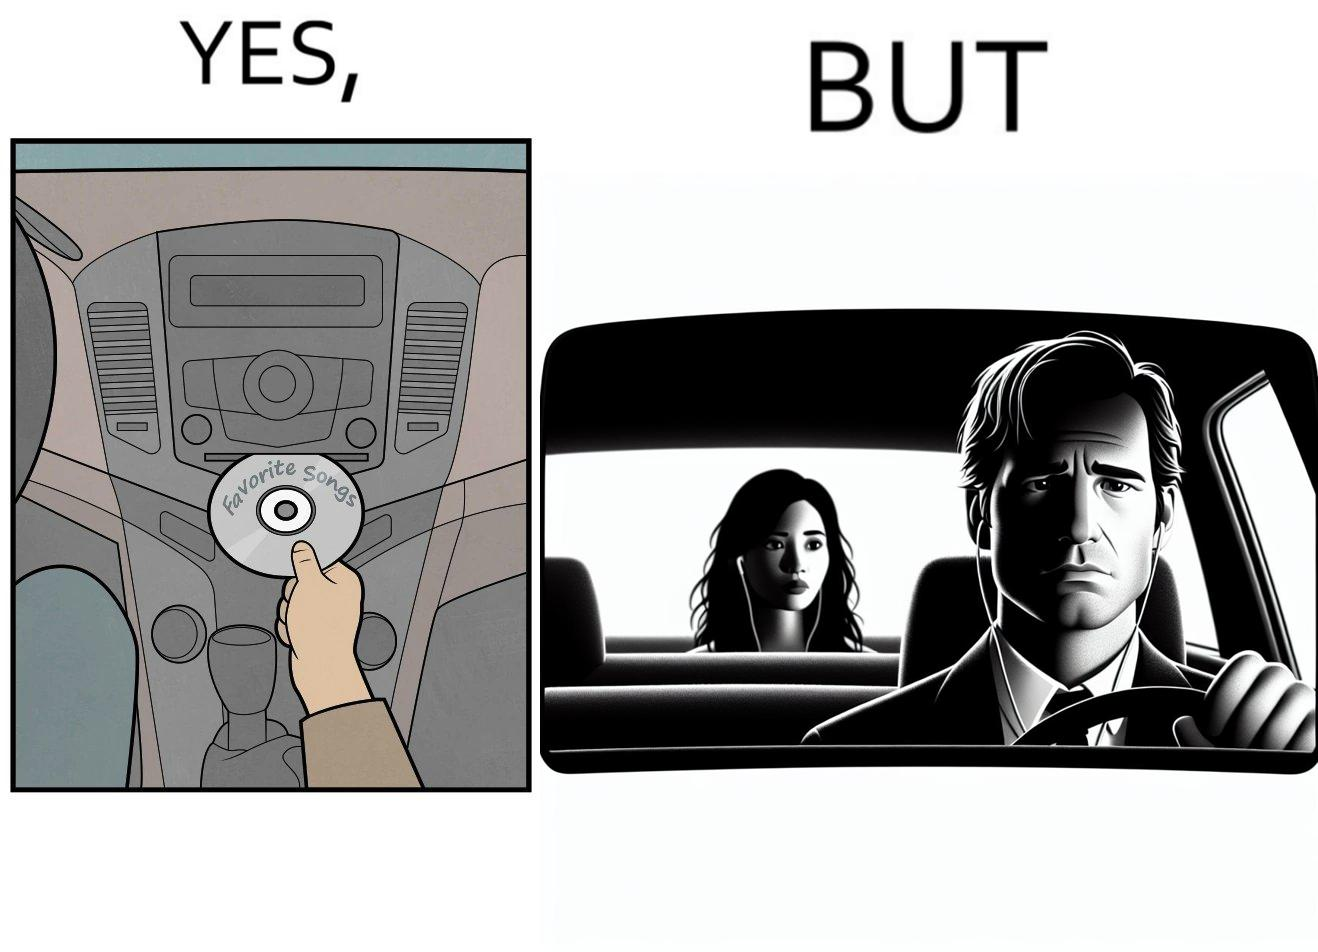What do you see in each half of this image? In the left part of the image: a person in the driving seat is inserting a CD with "Favorite Songs" written on it into the CD player of a car dashboard. In the right part of the image: driver of the car is sad on seeing the person (on the rear view mirror) sitting in the back seat of the car wearing earphones. 